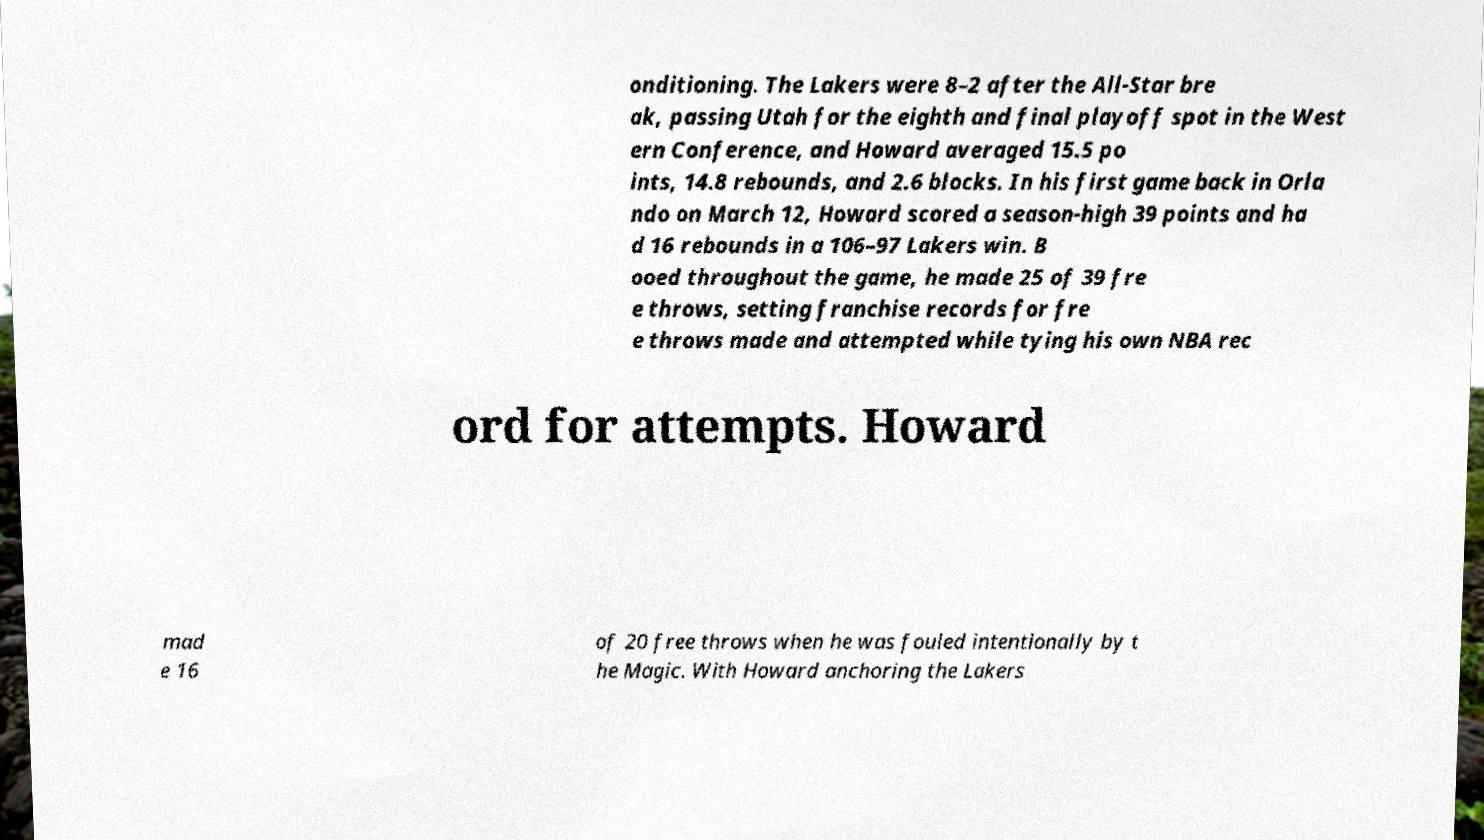For documentation purposes, I need the text within this image transcribed. Could you provide that? onditioning. The Lakers were 8–2 after the All-Star bre ak, passing Utah for the eighth and final playoff spot in the West ern Conference, and Howard averaged 15.5 po ints, 14.8 rebounds, and 2.6 blocks. In his first game back in Orla ndo on March 12, Howard scored a season-high 39 points and ha d 16 rebounds in a 106–97 Lakers win. B ooed throughout the game, he made 25 of 39 fre e throws, setting franchise records for fre e throws made and attempted while tying his own NBA rec ord for attempts. Howard mad e 16 of 20 free throws when he was fouled intentionally by t he Magic. With Howard anchoring the Lakers 